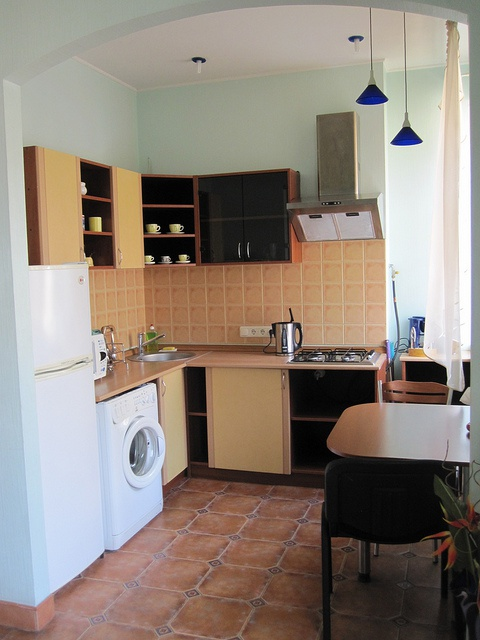Describe the objects in this image and their specific colors. I can see refrigerator in darkgray, lavender, and lightblue tones, chair in darkgray, black, maroon, and brown tones, dining table in darkgray, gray, brown, and lightgray tones, oven in darkgray, black, and gray tones, and potted plant in darkgray, black, maroon, olive, and gray tones in this image. 